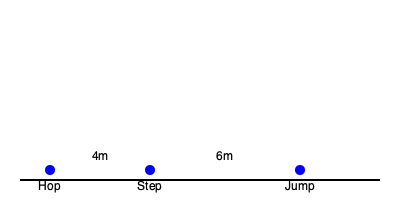Based on the diagram showing the footprint positions of a triple jump, estimate the total length of the jump if the hop distance is 4m and the step distance is 6m. To estimate the total length of the triple jump, we need to follow these steps:

1. Identify the components of a triple jump:
   - Hop: The first phase
   - Step: The second phase
   - Jump: The final phase

2. Analyze the given information:
   - Hop distance = 4m
   - Step distance = 6m
   - Jump distance is not provided

3. Estimate the jump distance:
   - In a well-executed triple jump, the three phases are typically distributed as follows:
     Hop ≈ 39%, Step ≈ 30%, Jump ≈ 31% of the total distance
   - We can use this distribution to estimate the jump distance
   - Let's calculate the total of hop and step: 4m + 6m = 10m
   - This represents approximately 69% of the total distance (39% + 30%)
   - To estimate the full distance, we can use the proportion:
     $\frac{10m}{0.69} \approx 14.49m$

4. Calculate the estimated jump distance:
   - Estimated total distance: 14.49m
   - Hop + Step = 10m
   - Jump = 14.49m - 10m ≈ 4.49m

5. Verify the distribution:
   - Hop: $\frac{4m}{14.49m} \approx 27.6\%$
   - Step: $\frac{6m}{14.49m} \approx 41.4\%$
   - Jump: $\frac{4.49m}{14.49m} \approx 31\%$

While this distribution is not perfect, it provides a reasonable estimate for the total jump length.
Answer: Approximately 14.5m 